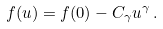<formula> <loc_0><loc_0><loc_500><loc_500>f ( u ) = f ( 0 ) - C _ { \gamma } u ^ { \gamma } \, .</formula> 